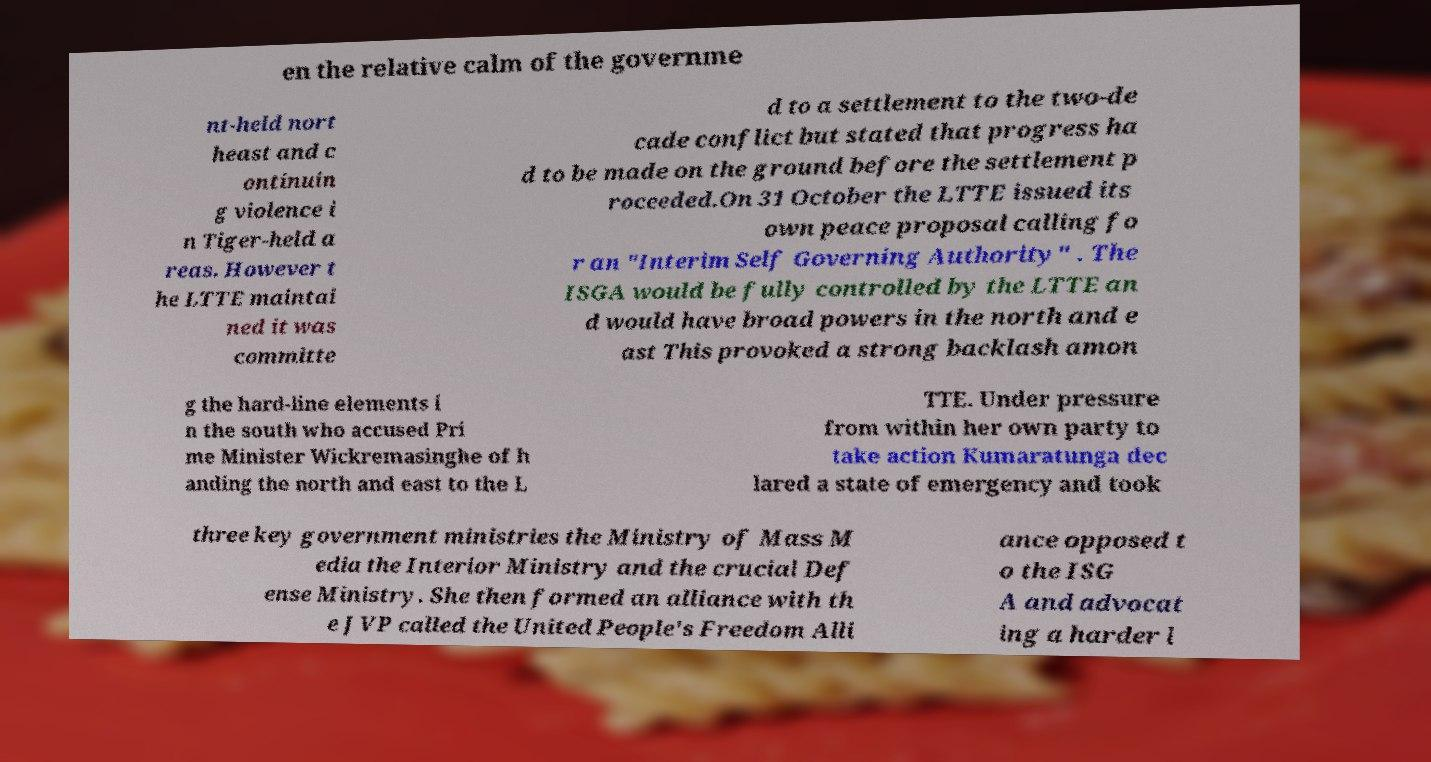Could you extract and type out the text from this image? en the relative calm of the governme nt-held nort heast and c ontinuin g violence i n Tiger-held a reas. However t he LTTE maintai ned it was committe d to a settlement to the two-de cade conflict but stated that progress ha d to be made on the ground before the settlement p roceeded.On 31 October the LTTE issued its own peace proposal calling fo r an "Interim Self Governing Authority" . The ISGA would be fully controlled by the LTTE an d would have broad powers in the north and e ast This provoked a strong backlash amon g the hard-line elements i n the south who accused Pri me Minister Wickremasinghe of h anding the north and east to the L TTE. Under pressure from within her own party to take action Kumaratunga dec lared a state of emergency and took three key government ministries the Ministry of Mass M edia the Interior Ministry and the crucial Def ense Ministry. She then formed an alliance with th e JVP called the United People's Freedom Alli ance opposed t o the ISG A and advocat ing a harder l 